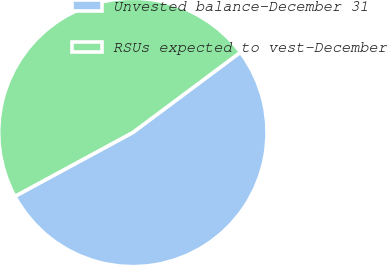Convert chart to OTSL. <chart><loc_0><loc_0><loc_500><loc_500><pie_chart><fcel>Unvested balance-December 31<fcel>RSUs expected to vest-December<nl><fcel>52.3%<fcel>47.7%<nl></chart> 